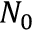Convert formula to latex. <formula><loc_0><loc_0><loc_500><loc_500>N _ { 0 }</formula> 